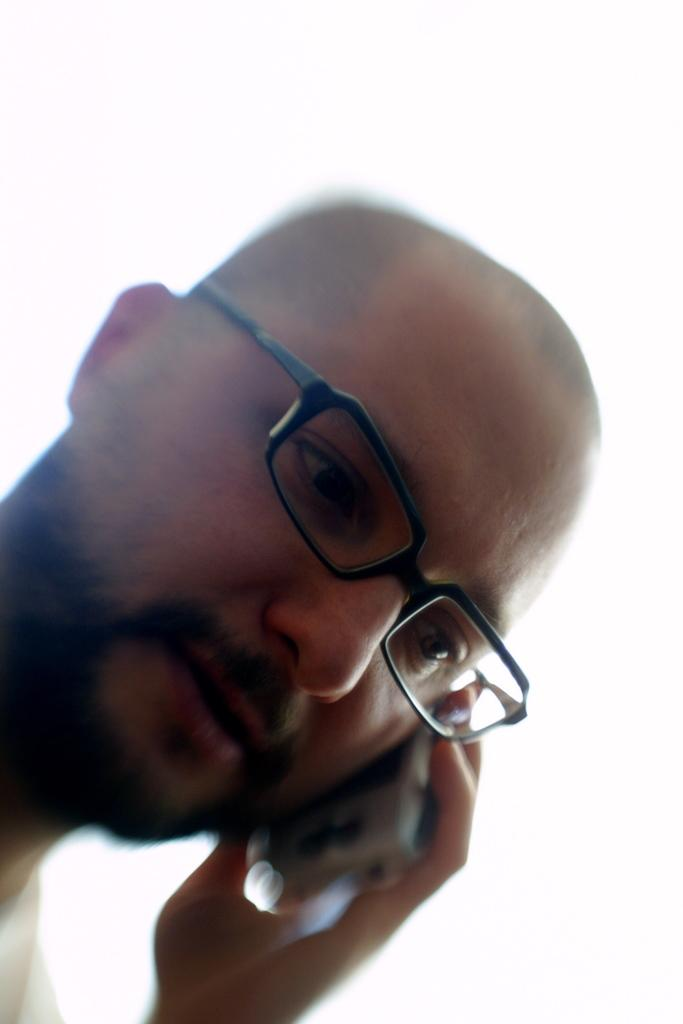Who is present in the image? There is a person in the image. What is the person doing in the image? The person is talking on a mobile phone. Can you describe any accessories the person is wearing? The person is wearing glasses (specs). What type of bean is the person holding in the image? There is no bean present in the image; the person is talking on a mobile phone and wearing glasses. 